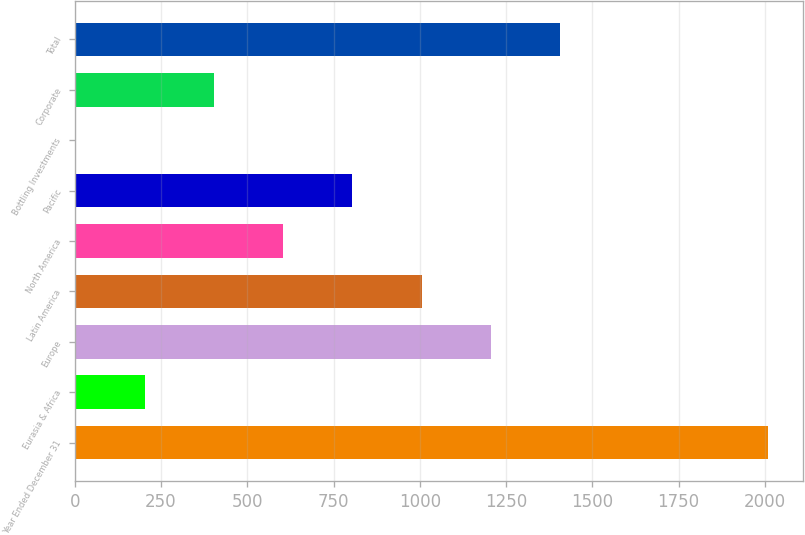Convert chart to OTSL. <chart><loc_0><loc_0><loc_500><loc_500><bar_chart><fcel>Year Ended December 31<fcel>Eurasia & Africa<fcel>Europe<fcel>Latin America<fcel>North America<fcel>Pacific<fcel>Bottling Investments<fcel>Corporate<fcel>Total<nl><fcel>2009<fcel>202.88<fcel>1206.28<fcel>1005.6<fcel>604.24<fcel>804.92<fcel>2.2<fcel>403.56<fcel>1406.96<nl></chart> 